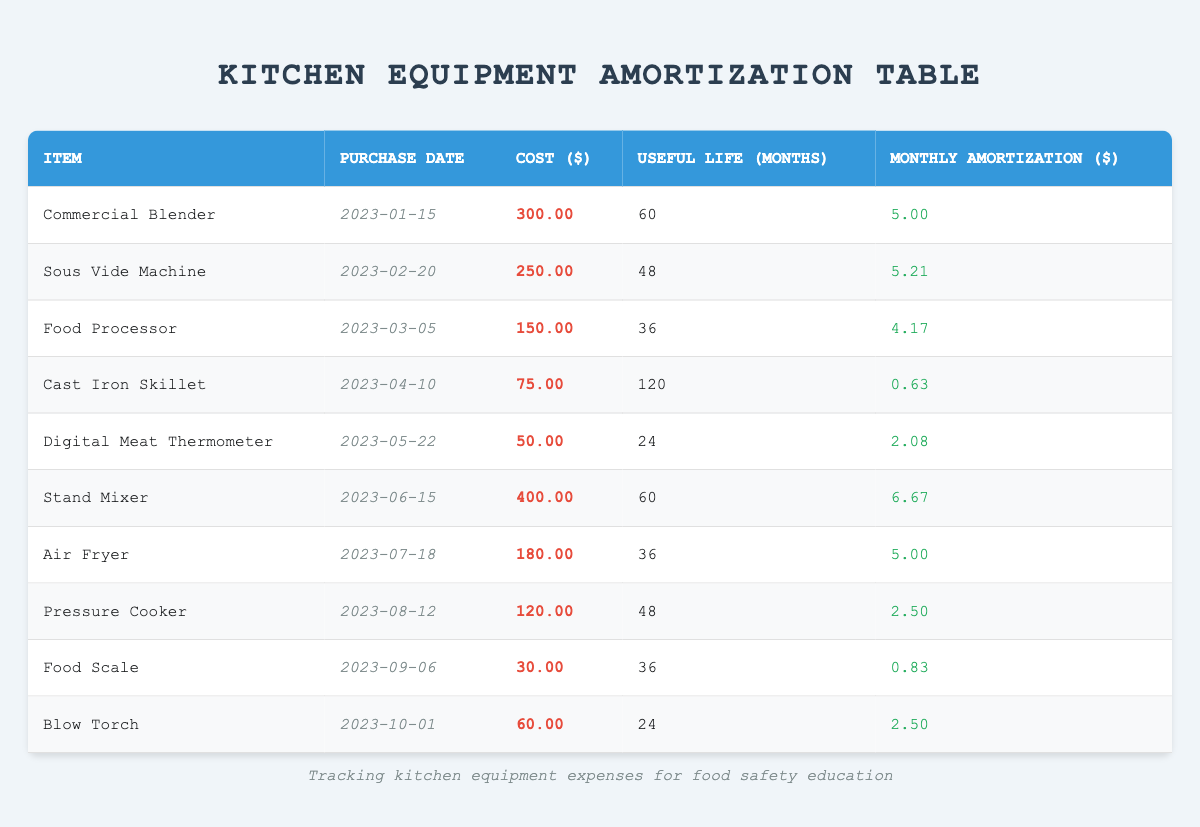What is the monthly amortization cost for the Stand Mixer? To find this, look for the row that contains the Stand Mixer. The monthly amortization for the Stand Mixer is listed as 6.67.
Answer: 6.67 How much did the Digital Meat Thermometer cost? The cost of the Digital Meat Thermometer can be found in the corresponding row, where it states the cost is 50.00.
Answer: 50.00 Which item has the longest useful life according to the table? Reviewing the useful life column, the Cast Iron Skillet has a useful life of 120 months, which is the highest value compared to other items.
Answer: Cast Iron Skillet What is the total monthly amortization cost for all kitchen equipment? Adding each monthly amortization together: 5.00 + 5.21 + 4.17 + 0.63 + 2.08 + 6.67 + 5.00 + 2.50 + 0.83 + 2.50 totals to 34.59.
Answer: 34.59 Did the Air Fryer have a purchase date before or after July? The purchase date for the Air Fryer is July 18, 2023. Thus, it was purchased in July, and so it is equal to the month of July, indicating the purchase was after June.
Answer: After Which item had the highest monthly amortization? Comparing the monthly amortization values, the Stand Mixer has the highest monthly amortization at 6.67.
Answer: Stand Mixer What is the average cost of the kitchen equipment bought so far? To calculate the average, sum all costs: 300 + 250 + 150 + 75 + 50 + 400 + 180 + 120 + 30 + 60 = 1615. There are 10 items, so the average cost is 1615/10 = 161.50.
Answer: 161.50 How many kitchen equipment items have a monthly amortization above 5 dollars? By examining the monthly amortization column, only the Stand Mixer and Sous Vide Machine have values above 5 dollars. Thus there are 2 items.
Answer: 2 What percentage of the equipment has a useful life of less than 36 months? From the table, there are three items (Digital Meat Thermometer, Food Scale, and Blow Torch) with a useful life of less than 36 months. Thus, the percentage is (3/10) * 100 = 30%.
Answer: 30% 